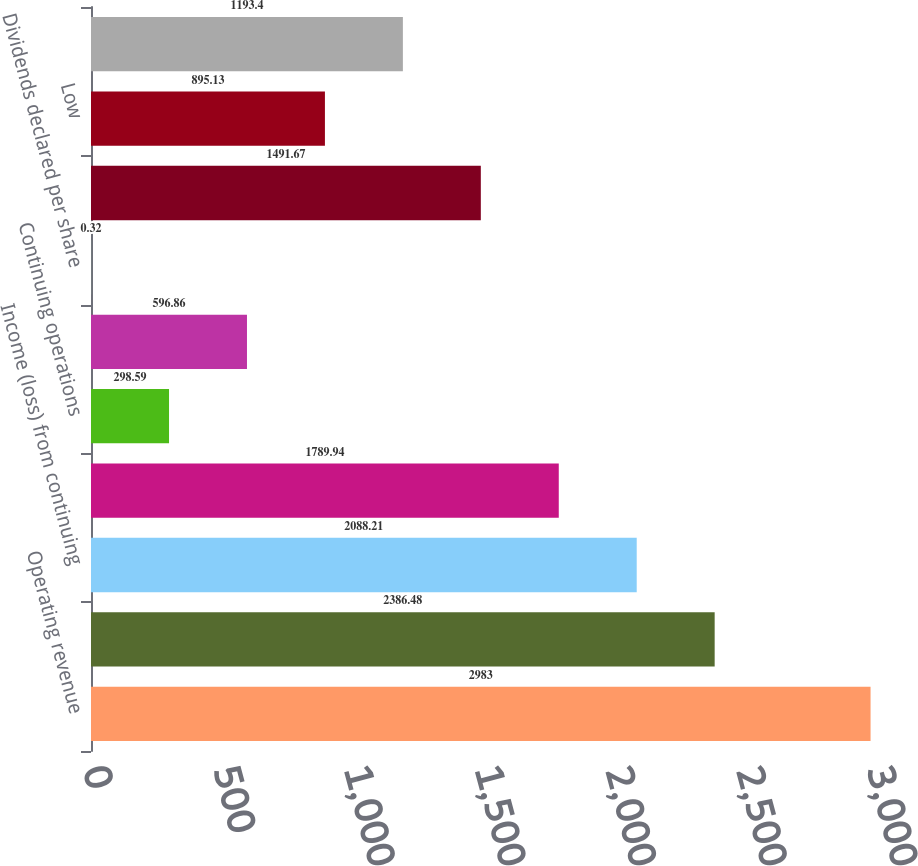Convert chart to OTSL. <chart><loc_0><loc_0><loc_500><loc_500><bar_chart><fcel>Operating revenue<fcel>Operating income (loss)<fcel>Income (loss) from continuing<fcel>Net income (loss) attributable<fcel>Continuing operations<fcel>Total<fcel>Dividends declared per share<fcel>High<fcel>Low<fcel>Close<nl><fcel>2983<fcel>2386.48<fcel>2088.21<fcel>1789.94<fcel>298.59<fcel>596.86<fcel>0.32<fcel>1491.67<fcel>895.13<fcel>1193.4<nl></chart> 